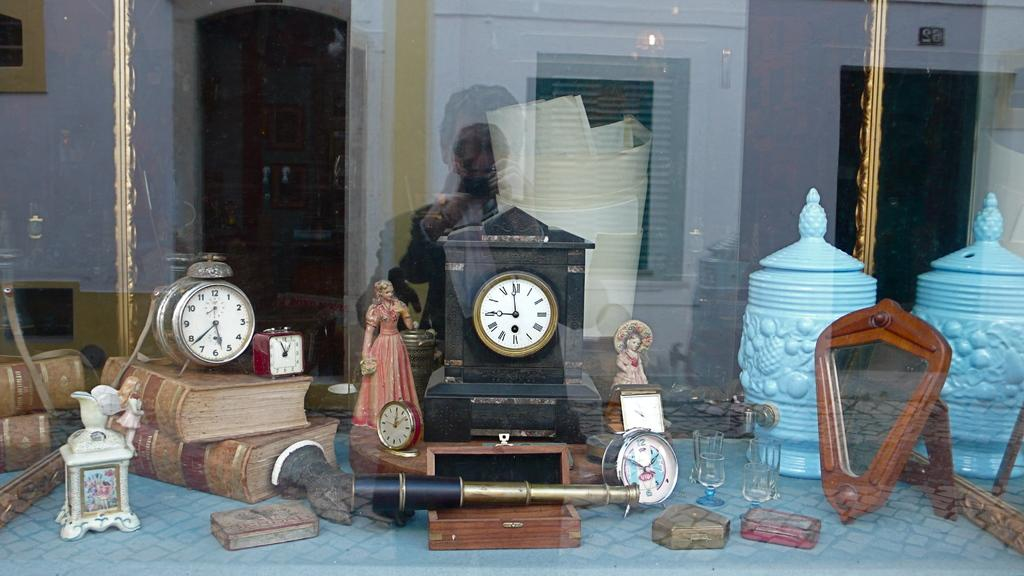Provide a one-sentence caption for the provided image. Several clocks, including one imprinted with the word Nevada, adorn a window display. 